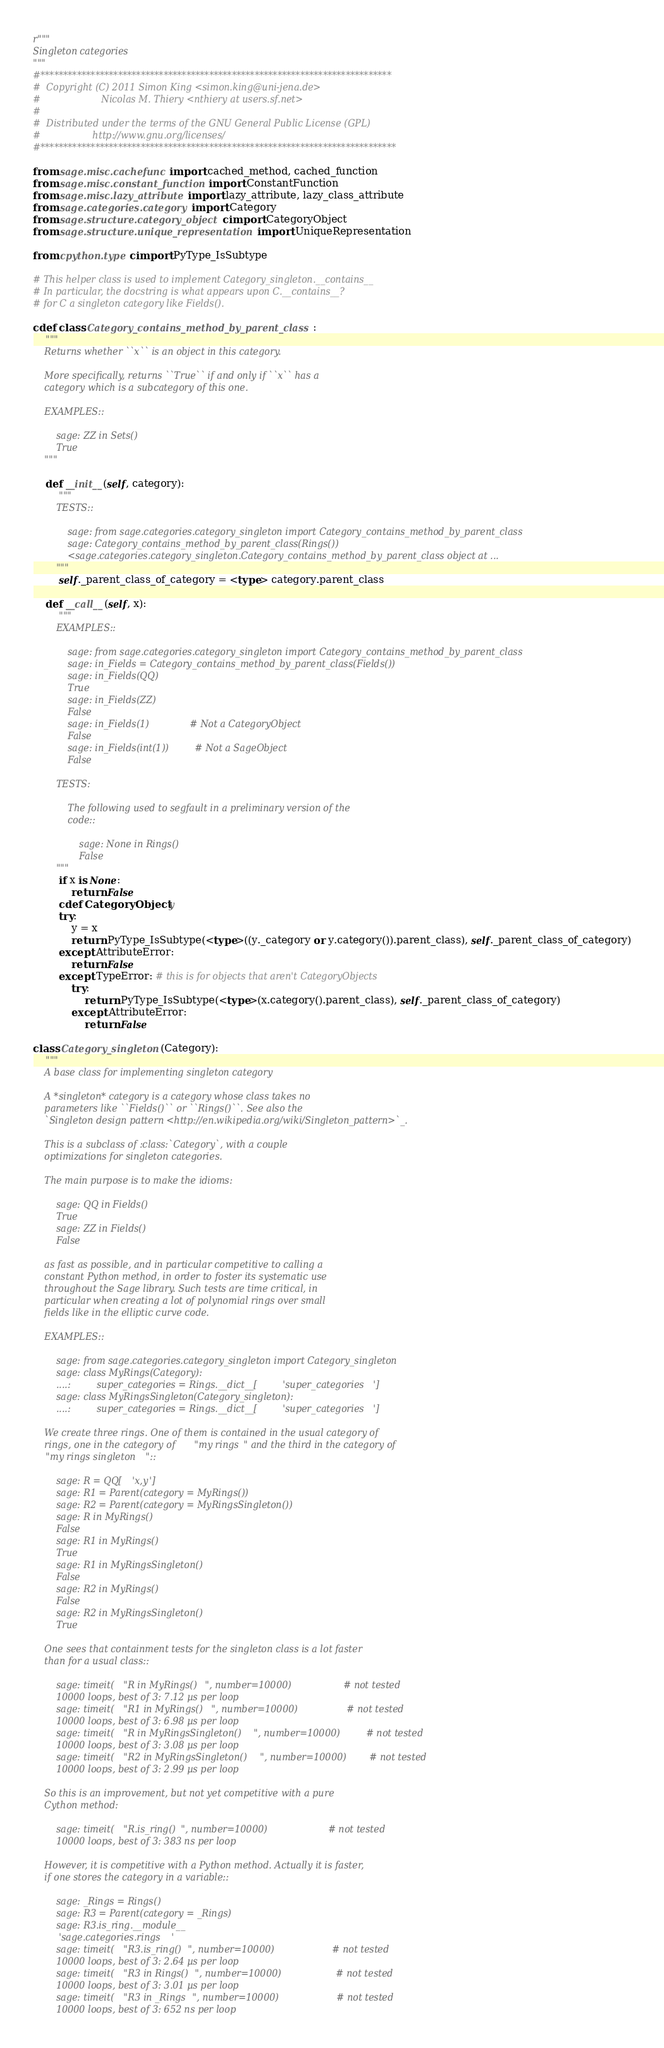Convert code to text. <code><loc_0><loc_0><loc_500><loc_500><_Cython_>r"""
Singleton categories
"""
#*****************************************************************************
#  Copyright (C) 2011 Simon King <simon.king@uni-jena.de>
#                     Nicolas M. Thiery <nthiery at users.sf.net>
#
#  Distributed under the terms of the GNU General Public License (GPL)
#                  http://www.gnu.org/licenses/
#******************************************************************************

from sage.misc.cachefunc import cached_method, cached_function
from sage.misc.constant_function import ConstantFunction
from sage.misc.lazy_attribute import lazy_attribute, lazy_class_attribute
from sage.categories.category import Category
from sage.structure.category_object cimport CategoryObject
from sage.structure.unique_representation import UniqueRepresentation

from cpython.type cimport PyType_IsSubtype

# This helper class is used to implement Category_singleton.__contains__
# In particular, the docstring is what appears upon C.__contains__?
# for C a singleton category like Fields().

cdef class Category_contains_method_by_parent_class:
    """
    Returns whether ``x`` is an object in this category.

    More specifically, returns ``True`` if and only if ``x`` has a
    category which is a subcategory of this one.

    EXAMPLES::

        sage: ZZ in Sets()
        True
    """

    def __init__(self, category):
        """
        TESTS::

            sage: from sage.categories.category_singleton import Category_contains_method_by_parent_class
            sage: Category_contains_method_by_parent_class(Rings())
            <sage.categories.category_singleton.Category_contains_method_by_parent_class object at ...
        """
        self._parent_class_of_category = <type> category.parent_class

    def __call__(self, x):
        """
        EXAMPLES::

            sage: from sage.categories.category_singleton import Category_contains_method_by_parent_class
            sage: in_Fields = Category_contains_method_by_parent_class(Fields())
            sage: in_Fields(QQ)
            True
            sage: in_Fields(ZZ)
            False
            sage: in_Fields(1)              # Not a CategoryObject
            False
            sage: in_Fields(int(1))         # Not a SageObject
            False

        TESTS:

            The following used to segfault in a preliminary version of the
            code::

                sage: None in Rings()
                False
        """
        if x is None:
            return False
        cdef CategoryObject y
        try:
            y = x
            return PyType_IsSubtype(<type>((y._category or y.category()).parent_class), self._parent_class_of_category)
        except AttributeError:
            return False
        except TypeError: # this is for objects that aren't CategoryObjects
            try:
                return PyType_IsSubtype(<type>(x.category().parent_class), self._parent_class_of_category)
            except AttributeError:
                return False

class Category_singleton(Category):
    """
    A base class for implementing singleton category

    A *singleton* category is a category whose class takes no
    parameters like ``Fields()`` or ``Rings()``. See also the
    `Singleton design pattern <http://en.wikipedia.org/wiki/Singleton_pattern>`_.

    This is a subclass of :class:`Category`, with a couple
    optimizations for singleton categories.

    The main purpose is to make the idioms:

        sage: QQ in Fields()
        True
        sage: ZZ in Fields()
        False

    as fast as possible, and in particular competitive to calling a
    constant Python method, in order to foster its systematic use
    throughout the Sage library. Such tests are time critical, in
    particular when creating a lot of polynomial rings over small
    fields like in the elliptic curve code.

    EXAMPLES::

        sage: from sage.categories.category_singleton import Category_singleton
        sage: class MyRings(Category):
        ....:         super_categories = Rings.__dict__['super_categories']
        sage: class MyRingsSingleton(Category_singleton):
        ....:         super_categories = Rings.__dict__['super_categories']

    We create three rings. One of them is contained in the usual category of
    rings, one in the category of "my rings" and the third in the category of
    "my rings singleton"::

        sage: R = QQ['x,y']
        sage: R1 = Parent(category = MyRings())
        sage: R2 = Parent(category = MyRingsSingleton())
        sage: R in MyRings()
        False
        sage: R1 in MyRings()
        True
        sage: R1 in MyRingsSingleton()
        False
        sage: R2 in MyRings()
        False
        sage: R2 in MyRingsSingleton()
        True

    One sees that containment tests for the singleton class is a lot faster
    than for a usual class::

        sage: timeit("R in MyRings()", number=10000)                  # not tested
        10000 loops, best of 3: 7.12 µs per loop
        sage: timeit("R1 in MyRings()", number=10000)                 # not tested
        10000 loops, best of 3: 6.98 µs per loop
        sage: timeit("R in MyRingsSingleton()", number=10000)         # not tested
        10000 loops, best of 3: 3.08 µs per loop
        sage: timeit("R2 in MyRingsSingleton()", number=10000)        # not tested
        10000 loops, best of 3: 2.99 µs per loop

    So this is an improvement, but not yet competitive with a pure
    Cython method:

        sage: timeit("R.is_ring()", number=10000)                     # not tested
        10000 loops, best of 3: 383 ns per loop

    However, it is competitive with a Python method. Actually it is faster,
    if one stores the category in a variable::

        sage: _Rings = Rings()
        sage: R3 = Parent(category = _Rings)
        sage: R3.is_ring.__module__
        'sage.categories.rings'
        sage: timeit("R3.is_ring()", number=10000)                    # not tested
        10000 loops, best of 3: 2.64 µs per loop
        sage: timeit("R3 in Rings()", number=10000)                   # not tested
        10000 loops, best of 3: 3.01 µs per loop
        sage: timeit("R3 in _Rings", number=10000)                    # not tested
        10000 loops, best of 3: 652 ns per loop
</code> 